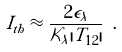<formula> <loc_0><loc_0><loc_500><loc_500>I _ { t h } \approx \frac { 2 \epsilon _ { \lambda } } { \mathcal { K } _ { \lambda } | T _ { 1 2 } | } \ .</formula> 